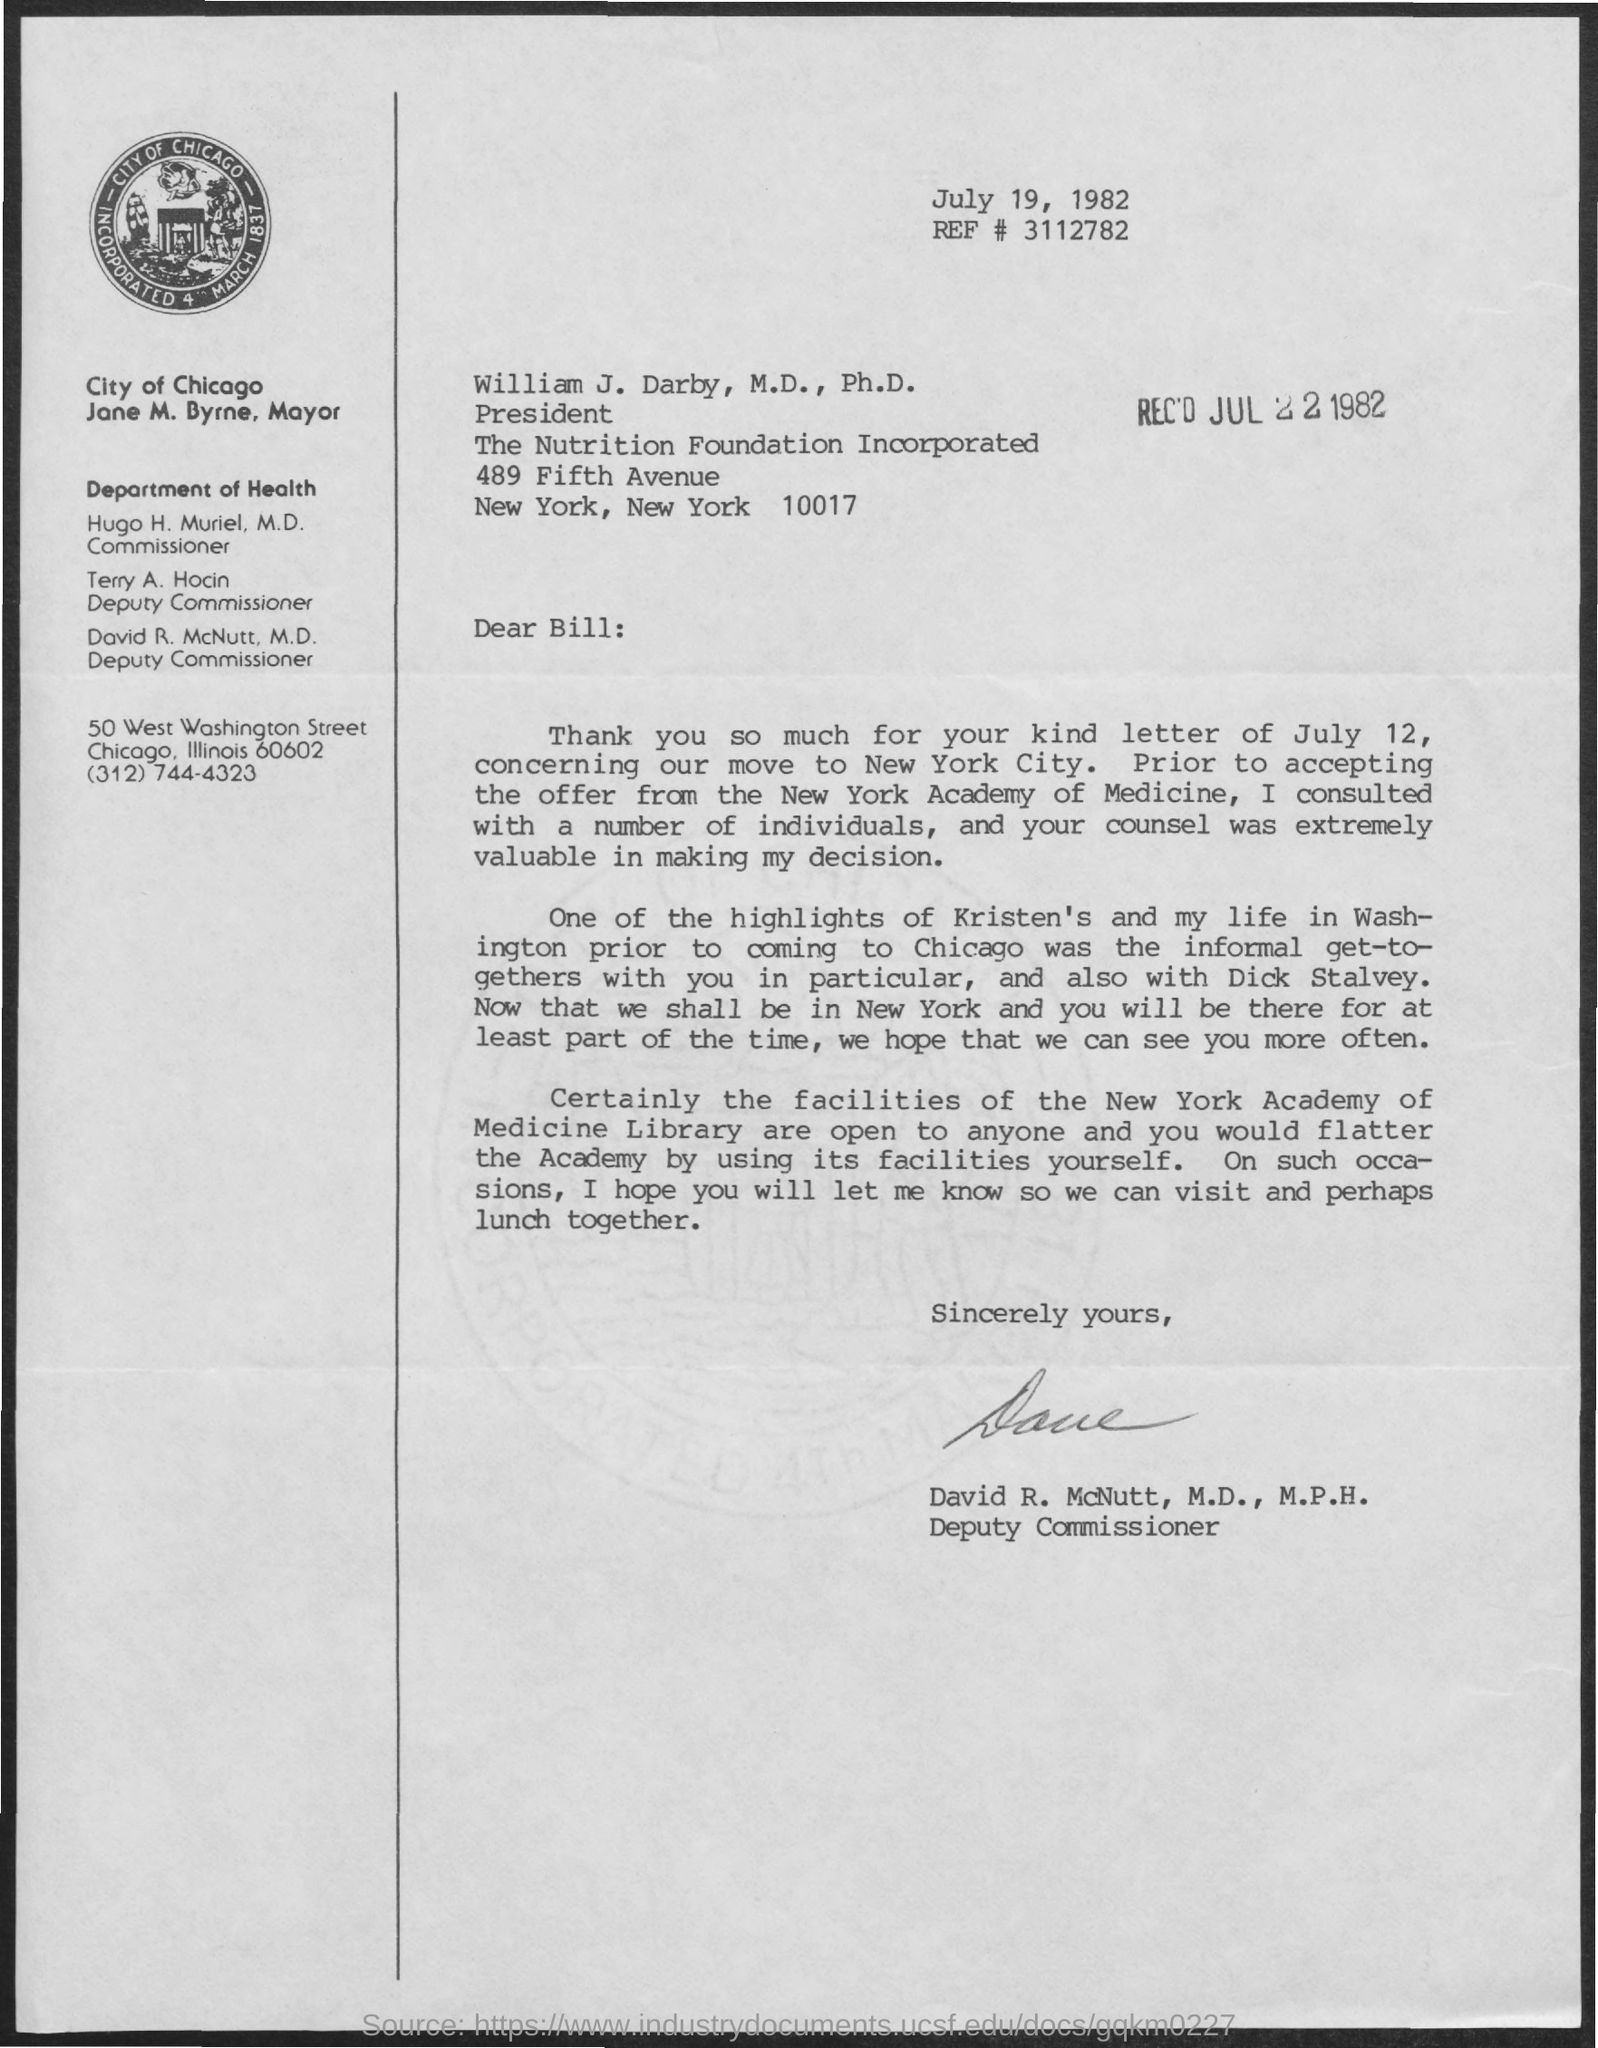On which date this letter was written ?
Your answer should be compact. July 19 , 1982. On which date this letter was received ?
Offer a very short reply. JUL 22, 1982. Who is the commissioner for the department of health ?
Offer a terse response. Hugo h. muriel. What is the designation of david r.mcnutt ?
Offer a terse response. Deputy commissioner. What is the ref # number written in the letter ?
Keep it short and to the point. 3112782. What is the designation of terry a. hocin ?
Keep it short and to the point. Deputy Commissioner. 